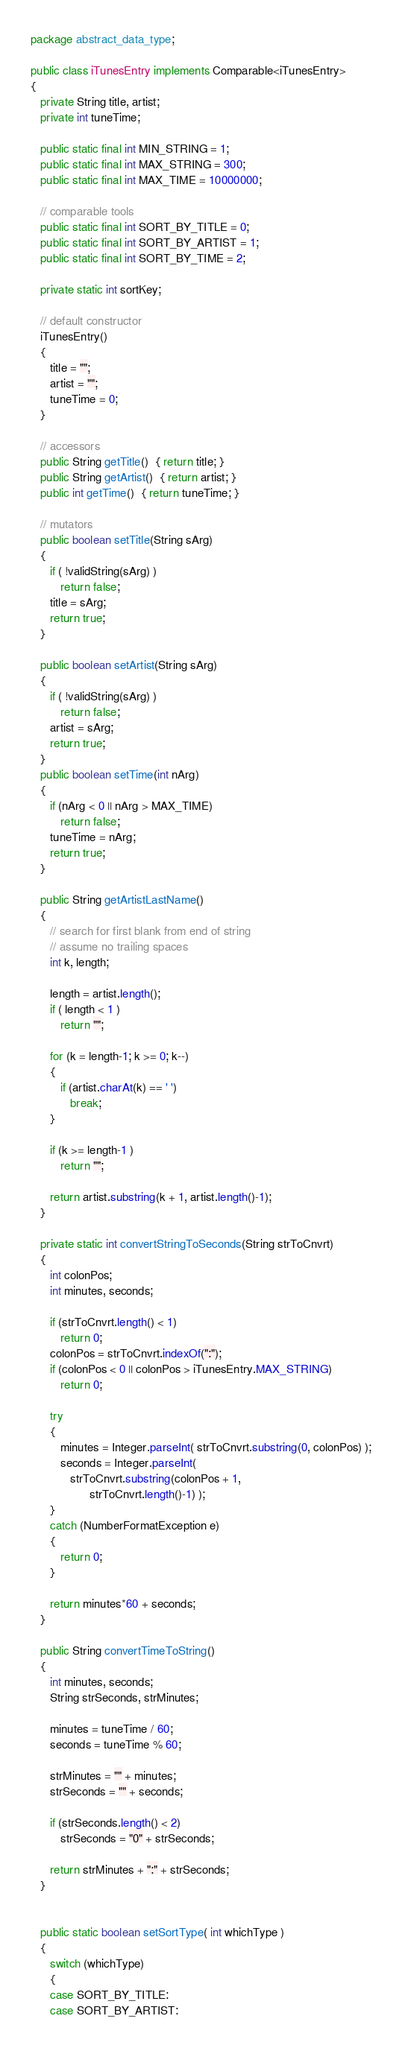Convert code to text. <code><loc_0><loc_0><loc_500><loc_500><_Java_>package abstract_data_type;

public class iTunesEntry implements Comparable<iTunesEntry>
{
   private String title, artist;
   private int tuneTime;

   public static final int MIN_STRING = 1;
   public static final int MAX_STRING = 300;
   public static final int MAX_TIME = 10000000;
   
   // comparable tools
   public static final int SORT_BY_TITLE = 0;
   public static final int SORT_BY_ARTIST = 1;
   public static final int SORT_BY_TIME = 2;

   private static int sortKey; 
   
   // default constructor
   iTunesEntry()
   {
      title = "";
      artist = "";
      tuneTime = 0;
   }
   
   // accessors
   public String getTitle()  { return title; }
   public String getArtist()  { return artist; }
   public int getTime()  { return tuneTime; }   
   
   // mutators
   public boolean setTitle(String sArg)
   {
      if ( !validString(sArg) )
         return false; 
      title = sArg;
      return true;
   }
   
   public boolean setArtist(String sArg)
   {
      if ( !validString(sArg) )
         return false;
      artist = sArg;
      return true;
   }
   public boolean setTime(int nArg)
   {
      if (nArg < 0 || nArg > MAX_TIME)
         return false;
      tuneTime = nArg;
      return true;
   }
   
   public String getArtistLastName()
   {
      // search for first blank from end of string
      // assume no trailing spaces
      int k, length;

      length = artist.length();
      if ( length < 1 )
         return "";

      for (k = length-1; k >= 0; k--)
      {
         if (artist.charAt(k) == ' ')
            break;
      }

      if (k >= length-1 )
         return "";

      return artist.substring(k + 1, artist.length()-1);
   }
   
   private static int convertStringToSeconds(String strToCnvrt)
   {
      int colonPos;
      int minutes, seconds;

      if (strToCnvrt.length() < 1)
         return 0;
      colonPos = strToCnvrt.indexOf(":");
      if (colonPos < 0 || colonPos > iTunesEntry.MAX_STRING)
         return 0;

      try
      {
         minutes = Integer.parseInt( strToCnvrt.substring(0, colonPos) );
         seconds = Integer.parseInt(
            strToCnvrt.substring(colonPos + 1, 
                  strToCnvrt.length()-1) );
      }
      catch (NumberFormatException e)
      {
         return 0;
      }

      return minutes*60 + seconds;
   }
   
   public String convertTimeToString() 
   {
      int minutes, seconds;
      String strSeconds, strMinutes;

      minutes = tuneTime / 60;
      seconds = tuneTime % 60;

      strMinutes = "" + minutes;
      strSeconds = "" + seconds;

      if (strSeconds.length() < 2)
         strSeconds = "0" + strSeconds;

      return strMinutes + ":" + strSeconds;
   }

  
   public static boolean setSortType( int whichType )
   {
      switch (whichType)
      {
      case SORT_BY_TITLE:
      case SORT_BY_ARTIST:</code> 